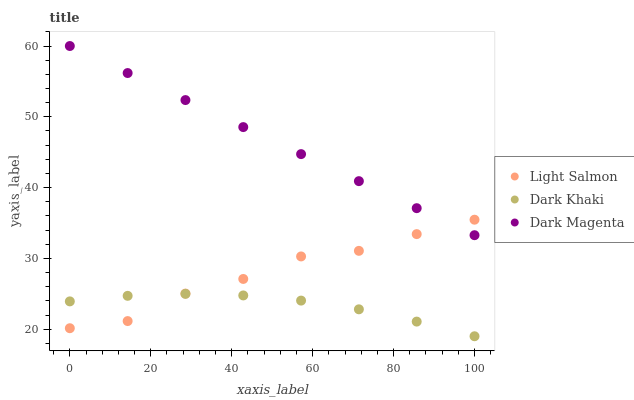Does Dark Khaki have the minimum area under the curve?
Answer yes or no. Yes. Does Dark Magenta have the maximum area under the curve?
Answer yes or no. Yes. Does Light Salmon have the minimum area under the curve?
Answer yes or no. No. Does Light Salmon have the maximum area under the curve?
Answer yes or no. No. Is Dark Magenta the smoothest?
Answer yes or no. Yes. Is Light Salmon the roughest?
Answer yes or no. Yes. Is Light Salmon the smoothest?
Answer yes or no. No. Is Dark Magenta the roughest?
Answer yes or no. No. Does Dark Khaki have the lowest value?
Answer yes or no. Yes. Does Light Salmon have the lowest value?
Answer yes or no. No. Does Dark Magenta have the highest value?
Answer yes or no. Yes. Does Light Salmon have the highest value?
Answer yes or no. No. Is Dark Khaki less than Dark Magenta?
Answer yes or no. Yes. Is Dark Magenta greater than Dark Khaki?
Answer yes or no. Yes. Does Dark Khaki intersect Light Salmon?
Answer yes or no. Yes. Is Dark Khaki less than Light Salmon?
Answer yes or no. No. Is Dark Khaki greater than Light Salmon?
Answer yes or no. No. Does Dark Khaki intersect Dark Magenta?
Answer yes or no. No. 